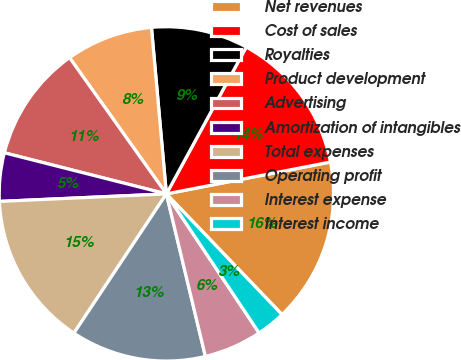Convert chart to OTSL. <chart><loc_0><loc_0><loc_500><loc_500><pie_chart><fcel>Net revenues<fcel>Cost of sales<fcel>Royalties<fcel>Product development<fcel>Advertising<fcel>Amortization of intangibles<fcel>Total expenses<fcel>Operating profit<fcel>Interest expense<fcel>Interest income<nl><fcel>15.89%<fcel>14.02%<fcel>9.35%<fcel>8.41%<fcel>11.21%<fcel>4.67%<fcel>14.95%<fcel>13.08%<fcel>5.61%<fcel>2.8%<nl></chart> 